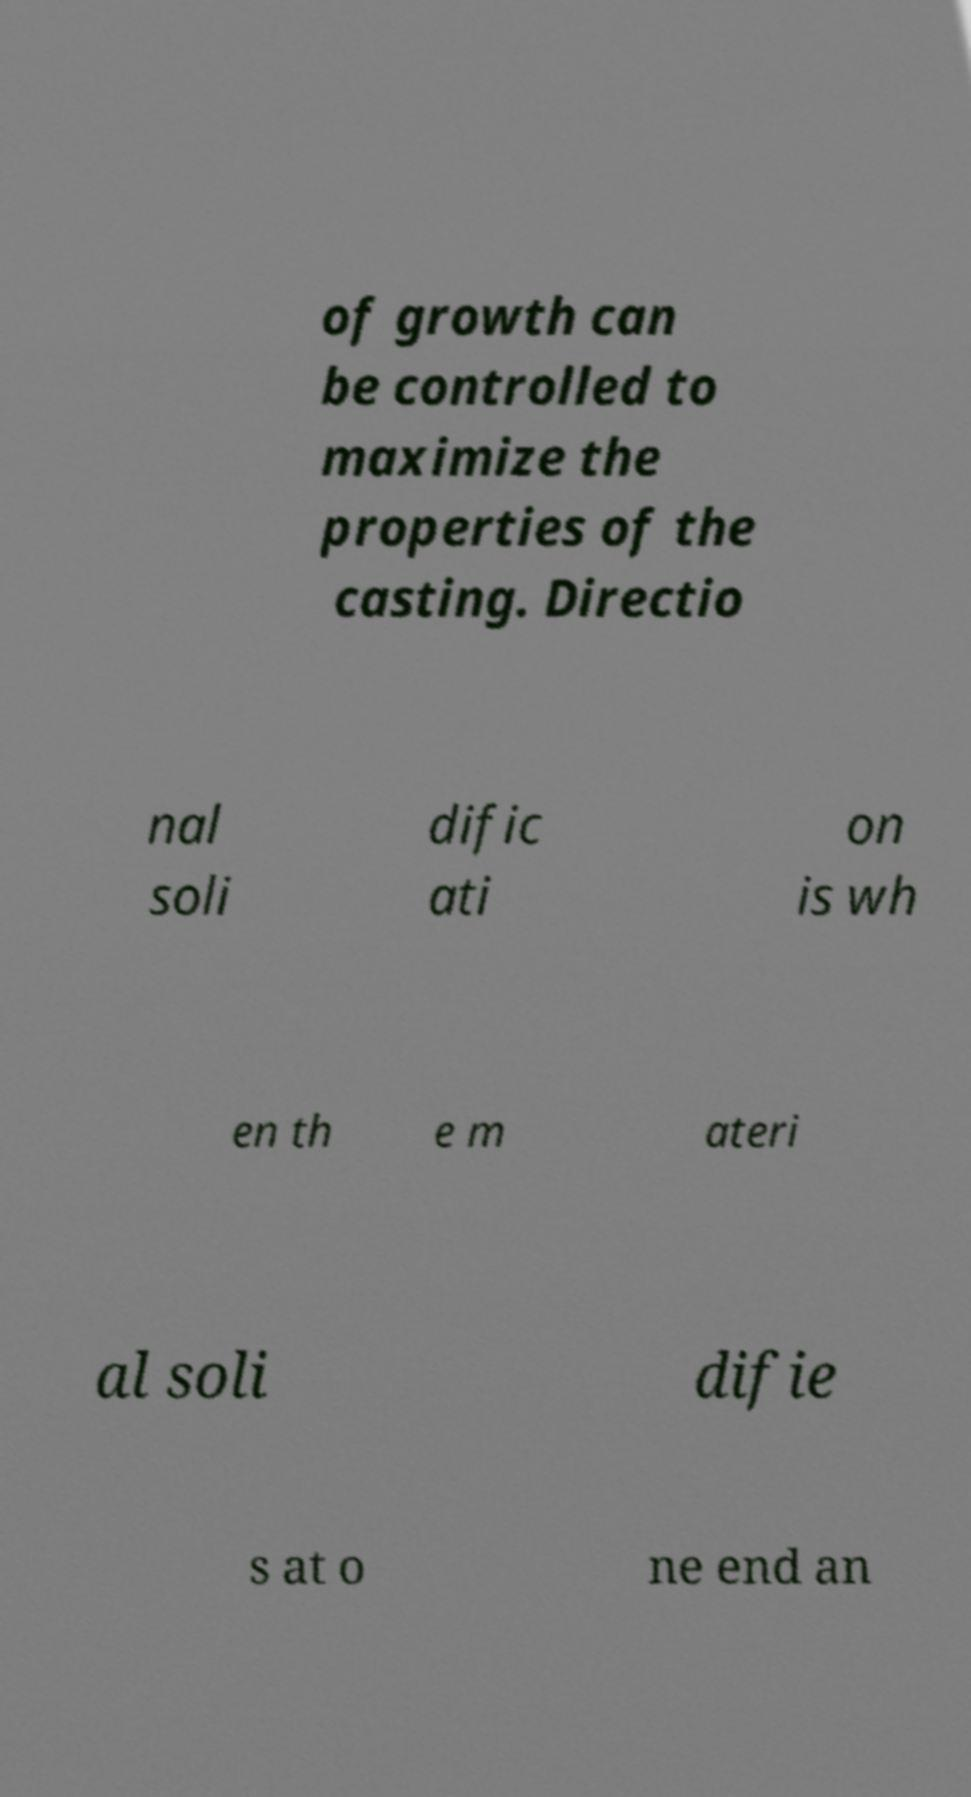There's text embedded in this image that I need extracted. Can you transcribe it verbatim? of growth can be controlled to maximize the properties of the casting. Directio nal soli dific ati on is wh en th e m ateri al soli difie s at o ne end an 